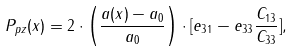<formula> <loc_0><loc_0><loc_500><loc_500>P _ { p z } ( x ) = 2 \cdot \left ( \frac { a ( x ) - a _ { 0 } } { a _ { 0 } } \right ) \cdot [ e _ { 3 1 } - e _ { 3 3 } \frac { C _ { 1 3 } } { C _ { 3 3 } } ] ,</formula> 